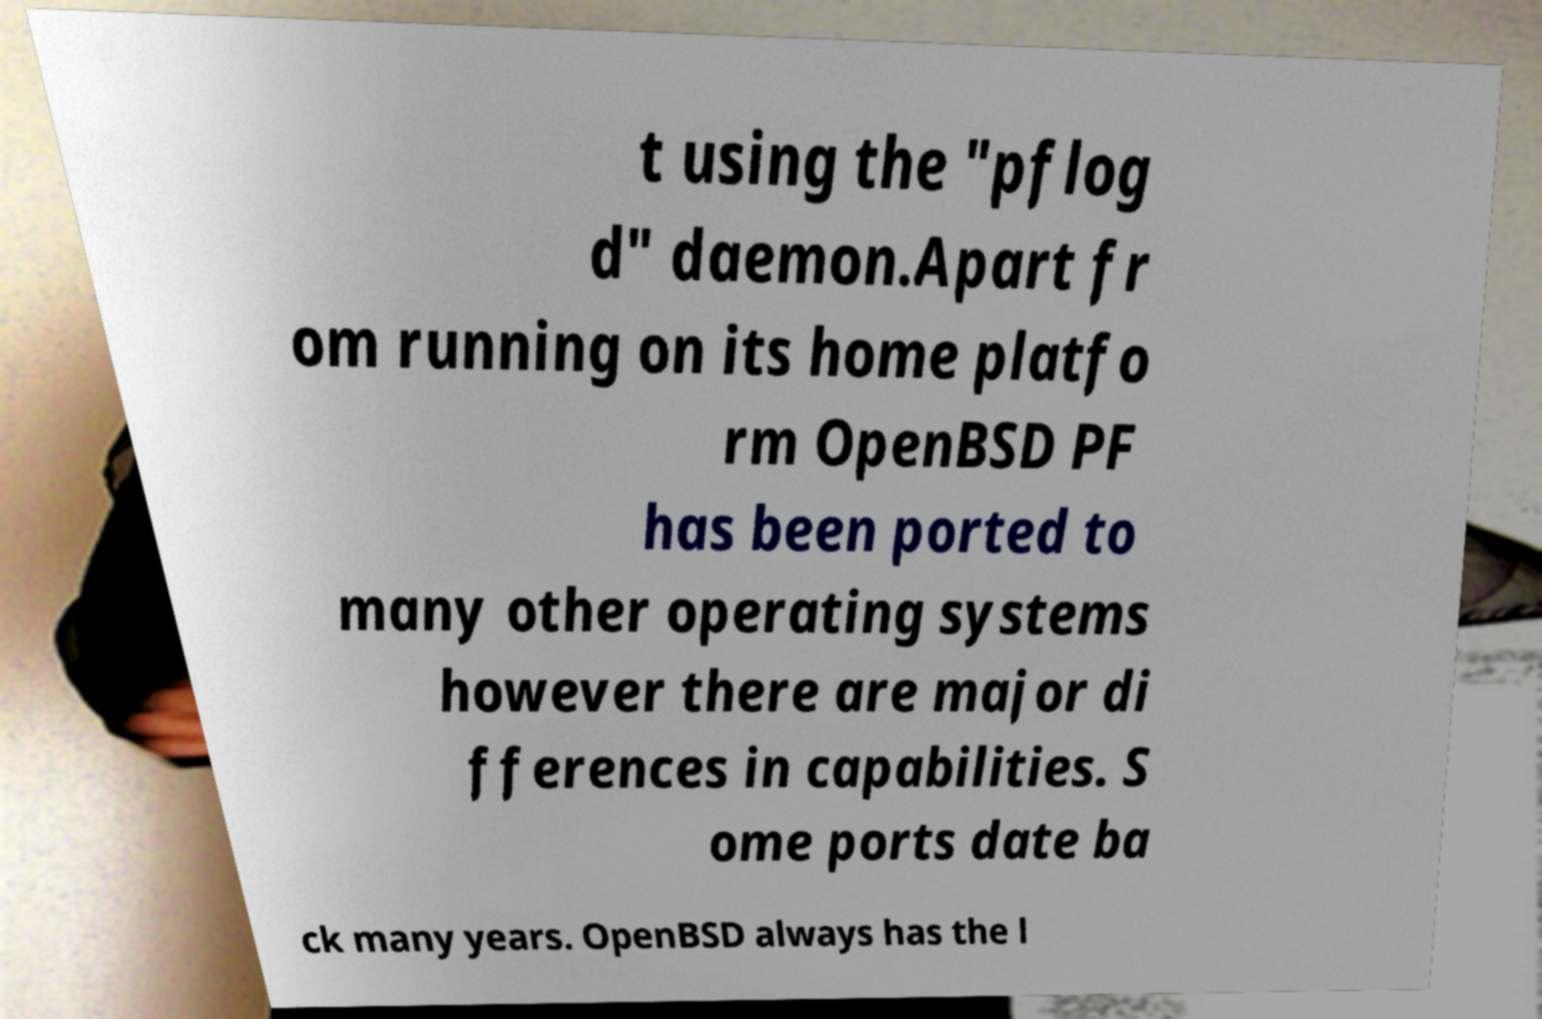Could you extract and type out the text from this image? t using the "pflog d" daemon.Apart fr om running on its home platfo rm OpenBSD PF has been ported to many other operating systems however there are major di fferences in capabilities. S ome ports date ba ck many years. OpenBSD always has the l 